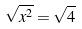<formula> <loc_0><loc_0><loc_500><loc_500>\sqrt { x ^ { 2 } } = \sqrt { 4 }</formula> 